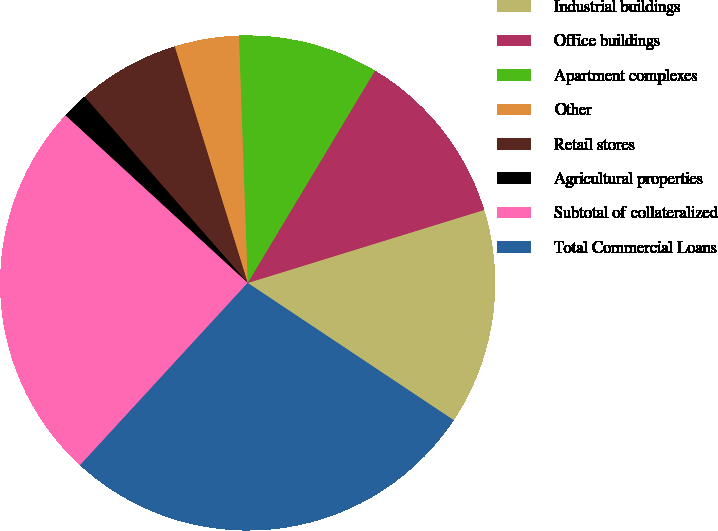<chart> <loc_0><loc_0><loc_500><loc_500><pie_chart><fcel>Industrial buildings<fcel>Office buildings<fcel>Apartment complexes<fcel>Other<fcel>Retail stores<fcel>Agricultural properties<fcel>Subtotal of collateralized<fcel>Total Commercial Loans<nl><fcel>14.12%<fcel>11.64%<fcel>9.16%<fcel>4.2%<fcel>6.68%<fcel>1.72%<fcel>25.0%<fcel>27.48%<nl></chart> 